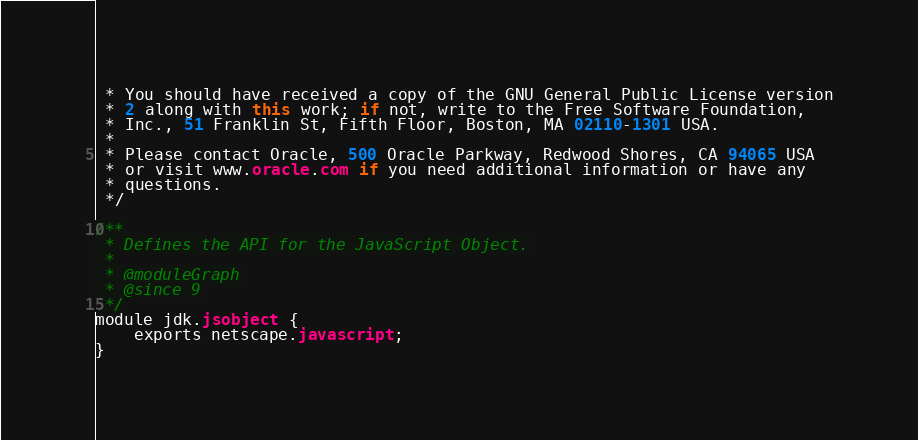Convert code to text. <code><loc_0><loc_0><loc_500><loc_500><_Java_> * You should have received a copy of the GNU General Public License version
 * 2 along with this work; if not, write to the Free Software Foundation,
 * Inc., 51 Franklin St, Fifth Floor, Boston, MA 02110-1301 USA.
 *
 * Please contact Oracle, 500 Oracle Parkway, Redwood Shores, CA 94065 USA
 * or visit www.oracle.com if you need additional information or have any
 * questions.
 */

/**
 * Defines the API for the JavaScript Object.
 *
 * @moduleGraph
 * @since 9
 */
module jdk.jsobject {
    exports netscape.javascript;
}
</code> 